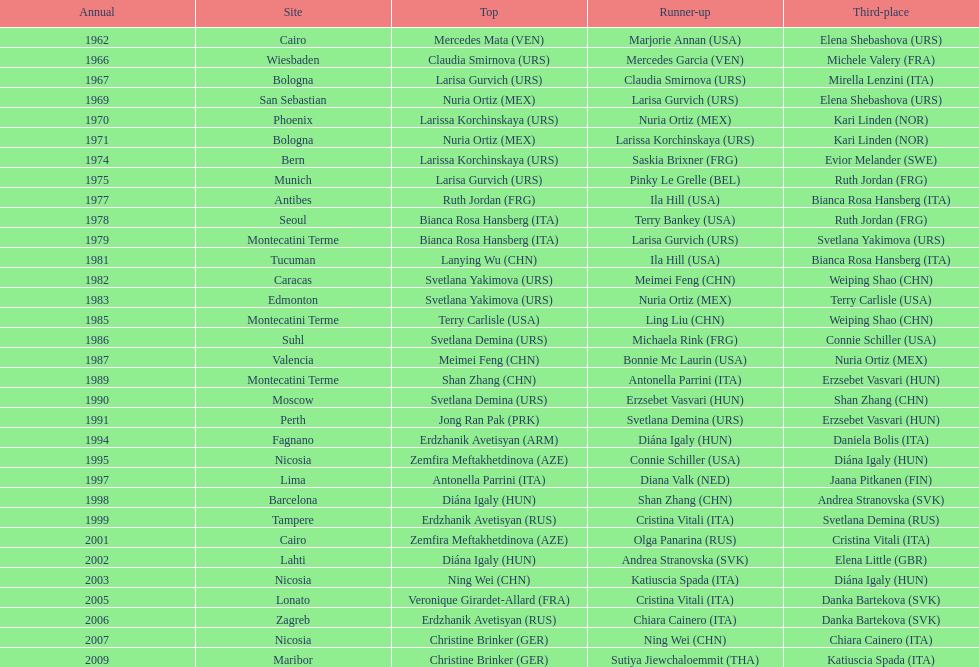What is the total of silver for cairo 0. 